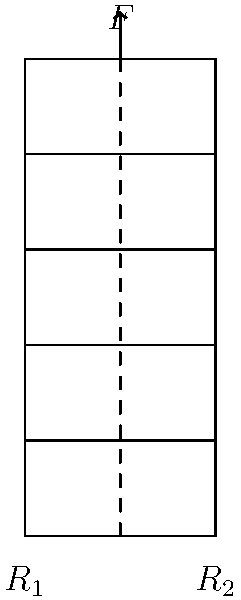In designing a miniature animated city building for a "Zootopia"-inspired set, you need to ensure structural integrity. The building is 5 units tall and 2 units wide, with a single central support column. If a downward force $F$ is applied at the top of the column, what is the minimum width-to-height ratio required to prevent the building from tipping, assuming the building's weight is negligible compared to $F$? To solve this problem, we'll follow these steps:

1) For the building to be stable, the moment about either base corner should be zero or positive when the force is applied.

2) Let's consider the moment about the left corner (R1). For stability:

   $F \cdot (\text{width}/2) \geq F \cdot \text{height}$

3) This is because the stabilizing moment is $F \cdot (\text{width}/2)$, and the tipping moment is $F \cdot \text{height}$.

4) Simplifying the inequality:

   $\text{width}/2 \geq \text{height}$

5) Rearranging to get the width-to-height ratio:

   $\text{width}/\text{height} \geq 2$

6) Therefore, the minimum width-to-height ratio to prevent tipping is 2:1.

In the context of our miniature animated city, this means the building's base should be at least 2/5 as wide as it is tall to ensure it doesn't tip over when force is applied to the top of the central support column.
Answer: 2:1 